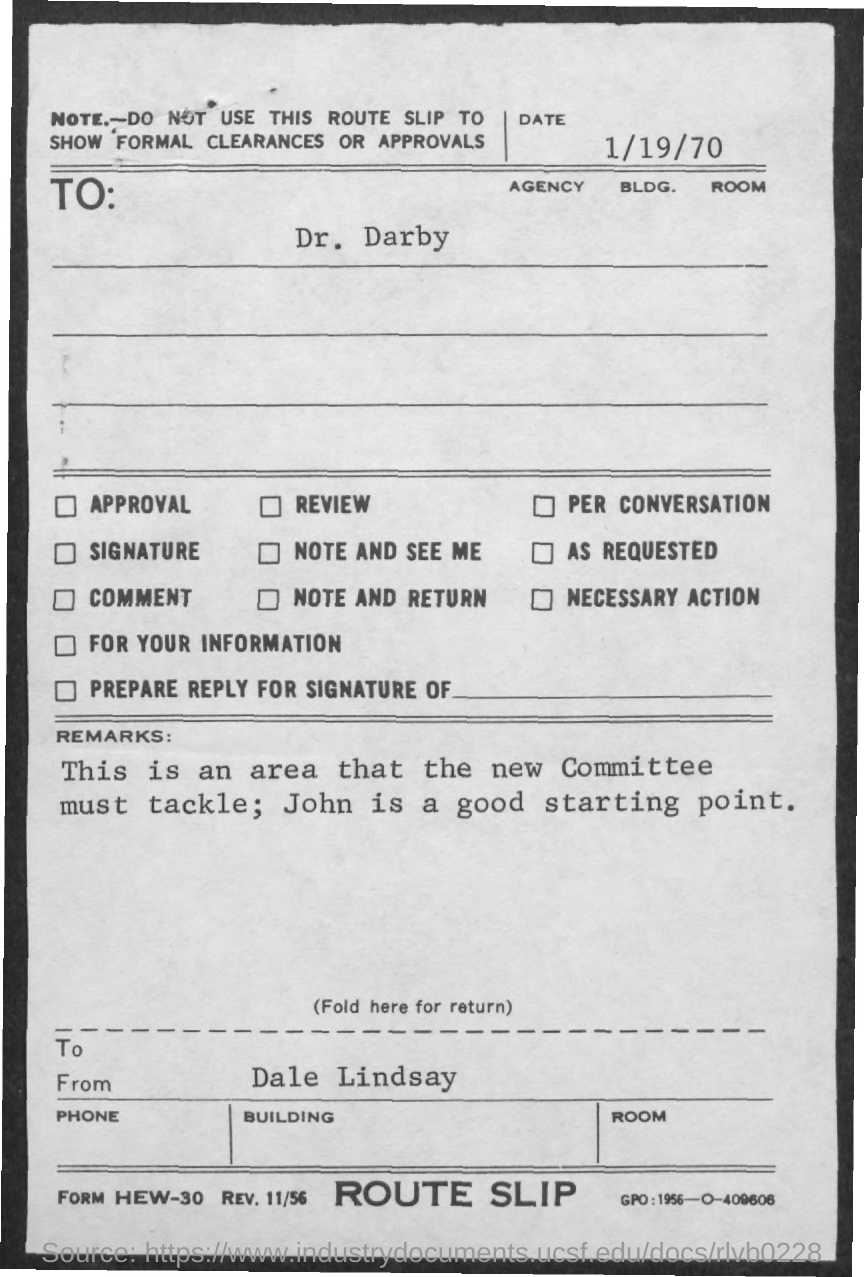Who is it addressed to?
Make the answer very short. Dr. Darby. Who is a good starting point?
Provide a succinct answer. John. Who is this from?
Offer a terse response. Dale Lindsay. 